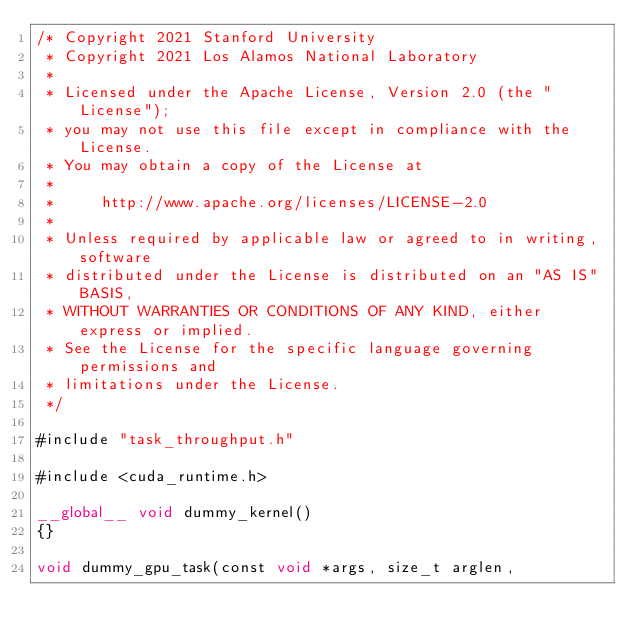Convert code to text. <code><loc_0><loc_0><loc_500><loc_500><_Cuda_>/* Copyright 2021 Stanford University
 * Copyright 2021 Los Alamos National Laboratory 
 *
 * Licensed under the Apache License, Version 2.0 (the "License");
 * you may not use this file except in compliance with the License.
 * You may obtain a copy of the License at
 *
 *     http://www.apache.org/licenses/LICENSE-2.0
 *
 * Unless required by applicable law or agreed to in writing, software
 * distributed under the License is distributed on an "AS IS" BASIS,
 * WITHOUT WARRANTIES OR CONDITIONS OF ANY KIND, either express or implied.
 * See the License for the specific language governing permissions and
 * limitations under the License.
 */

#include "task_throughput.h"

#include <cuda_runtime.h>

__global__ void dummy_kernel()
{}

void dummy_gpu_task(const void *args, size_t arglen, </code> 